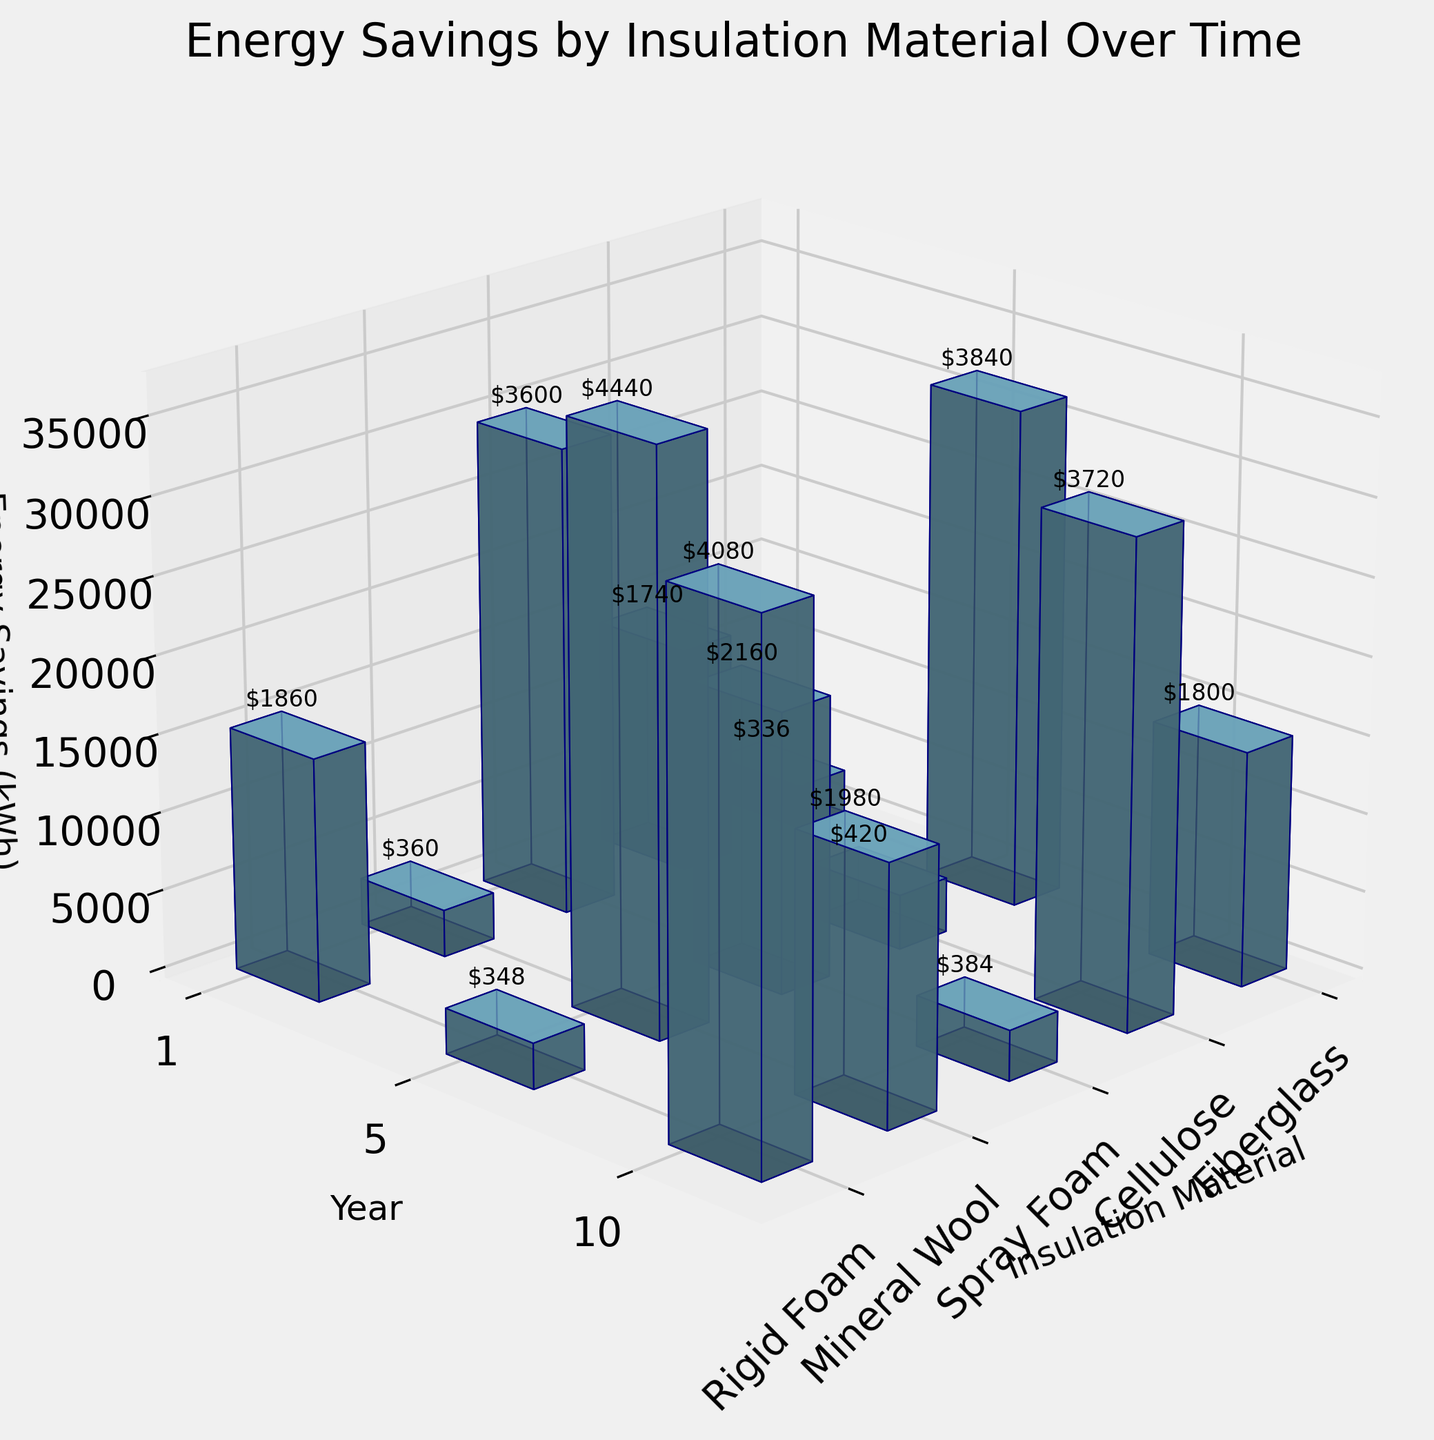What is the title of the 3D bar plot? Look at the top of the figure where the title is usually placed. It reads "Energy Savings by Insulation Material Over Time."
Answer: Energy Savings by Insulation Material Over Time Which insulation material shows the highest energy savings in the first year? Look at the z-axis values corresponding to the 'Year 1' tick on the y-axis. Identify the bar with the highest value among the materials. Spray Foam shows the highest energy savings in the first year at 3500 kWh.
Answer: Spray Foam What is the average cost savings of Fiberglass over the 10-year period? Sum the cost savings for each year for Fiberglass (336, 1740, 3600) and divide by the number of years (3). The average is (336 + 1740 + 3600) / 3 = 5676 / 3 = 1892.
Answer: 1892 Which material has the greatest total energy savings after 10 years? Compare the energy savings values at the 10-year mark for all materials. Spray Foam has the highest value at 37000 kWh.
Answer: Spray Foam How does the cost savings of Rigid Foam after 5 years compare to Cellulose after 10 years? Identify the cost savings values for Rigid Foam at year 5 (1980) and Cellulose at year 10 (3840). Compare these two values. 1980 (Rigid Foam) is less than 3840 (Cellulose).
Answer: Less How much more energy does Rigid Foam save compared to Fiberglass after 1 year? Identify the energy savings after 1 year for both Rigid Foam (3200 kWh) and Fiberglass (2800 kWh). Subtract Fiberglass savings from Rigid Foam savings: 3200 - 2800 = 400 kWh.
Answer: 400 kWh What is the sum of energy savings after 5 years for all materials combined? Sum the 5-year energy savings for all materials: Fiberglass (14500), Cellulose (15500), Spray Foam (18000), Mineral Wool (15000), and Rigid Foam (16500). The total is 14500 + 15500 + 18000 + 15000 + 16500 = 79500 kWh.
Answer: 79500 kWh From which viewing angle is the plot visualized? Look at the perspective of the plot. The common viewing angles are defined by the elevation and azimuthal angles, noted in the code as 'elev=20' and 'azim=45'.
Answer: 20° elev, 45° azim Which material has the lowest cost savings over 5 years? Compare the cost savings values for all materials at the 5-year mark. Mineral Wool has the lowest at $1800.
Answer: Mineral Wool 